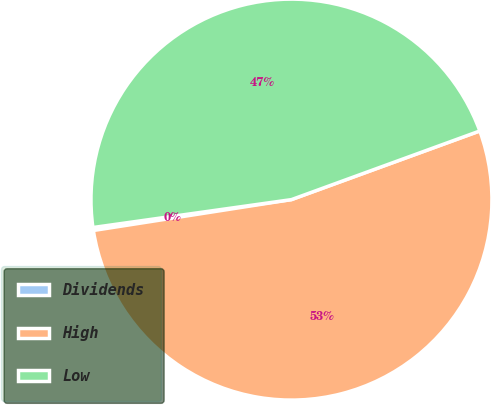Convert chart. <chart><loc_0><loc_0><loc_500><loc_500><pie_chart><fcel>Dividends<fcel>High<fcel>Low<nl><fcel>0.24%<fcel>53.1%<fcel>46.66%<nl></chart> 